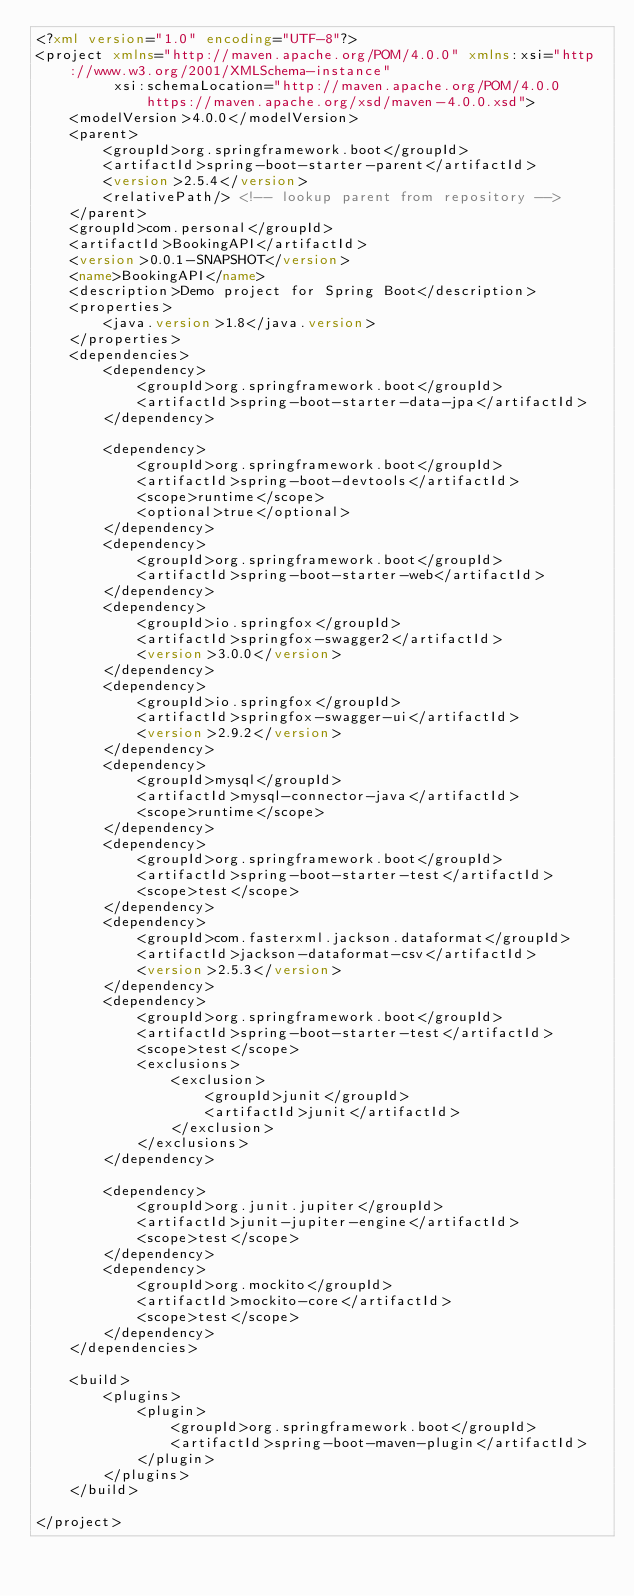Convert code to text. <code><loc_0><loc_0><loc_500><loc_500><_XML_><?xml version="1.0" encoding="UTF-8"?>
<project xmlns="http://maven.apache.org/POM/4.0.0" xmlns:xsi="http://www.w3.org/2001/XMLSchema-instance"
         xsi:schemaLocation="http://maven.apache.org/POM/4.0.0 https://maven.apache.org/xsd/maven-4.0.0.xsd">
    <modelVersion>4.0.0</modelVersion>
    <parent>
        <groupId>org.springframework.boot</groupId>
        <artifactId>spring-boot-starter-parent</artifactId>
        <version>2.5.4</version>
        <relativePath/> <!-- lookup parent from repository -->
    </parent>
    <groupId>com.personal</groupId>
    <artifactId>BookingAPI</artifactId>
    <version>0.0.1-SNAPSHOT</version>
    <name>BookingAPI</name>
    <description>Demo project for Spring Boot</description>
    <properties>
        <java.version>1.8</java.version>
    </properties>
    <dependencies>
        <dependency>
            <groupId>org.springframework.boot</groupId>
            <artifactId>spring-boot-starter-data-jpa</artifactId>
        </dependency>

        <dependency>
            <groupId>org.springframework.boot</groupId>
            <artifactId>spring-boot-devtools</artifactId>
            <scope>runtime</scope>
            <optional>true</optional>
        </dependency>
        <dependency>
            <groupId>org.springframework.boot</groupId>
            <artifactId>spring-boot-starter-web</artifactId>
        </dependency>
        <dependency>
            <groupId>io.springfox</groupId>
            <artifactId>springfox-swagger2</artifactId>
            <version>3.0.0</version>
        </dependency>
        <dependency>
            <groupId>io.springfox</groupId>
            <artifactId>springfox-swagger-ui</artifactId>
            <version>2.9.2</version>
        </dependency>
        <dependency>
            <groupId>mysql</groupId>
            <artifactId>mysql-connector-java</artifactId>
            <scope>runtime</scope>
        </dependency>
        <dependency>
            <groupId>org.springframework.boot</groupId>
            <artifactId>spring-boot-starter-test</artifactId>
            <scope>test</scope>
        </dependency>
        <dependency>
            <groupId>com.fasterxml.jackson.dataformat</groupId>
            <artifactId>jackson-dataformat-csv</artifactId>
            <version>2.5.3</version>
        </dependency>
        <dependency>
            <groupId>org.springframework.boot</groupId>
            <artifactId>spring-boot-starter-test</artifactId>
            <scope>test</scope>
            <exclusions>
                <exclusion>
                    <groupId>junit</groupId>
                    <artifactId>junit</artifactId>
                </exclusion>
            </exclusions>
        </dependency>

        <dependency>
            <groupId>org.junit.jupiter</groupId>
            <artifactId>junit-jupiter-engine</artifactId>
            <scope>test</scope>
        </dependency>
        <dependency>
            <groupId>org.mockito</groupId>
            <artifactId>mockito-core</artifactId>
            <scope>test</scope>
        </dependency>
    </dependencies>

    <build>
        <plugins>
            <plugin>
                <groupId>org.springframework.boot</groupId>
                <artifactId>spring-boot-maven-plugin</artifactId>
            </plugin>
        </plugins>
    </build>

</project>
</code> 